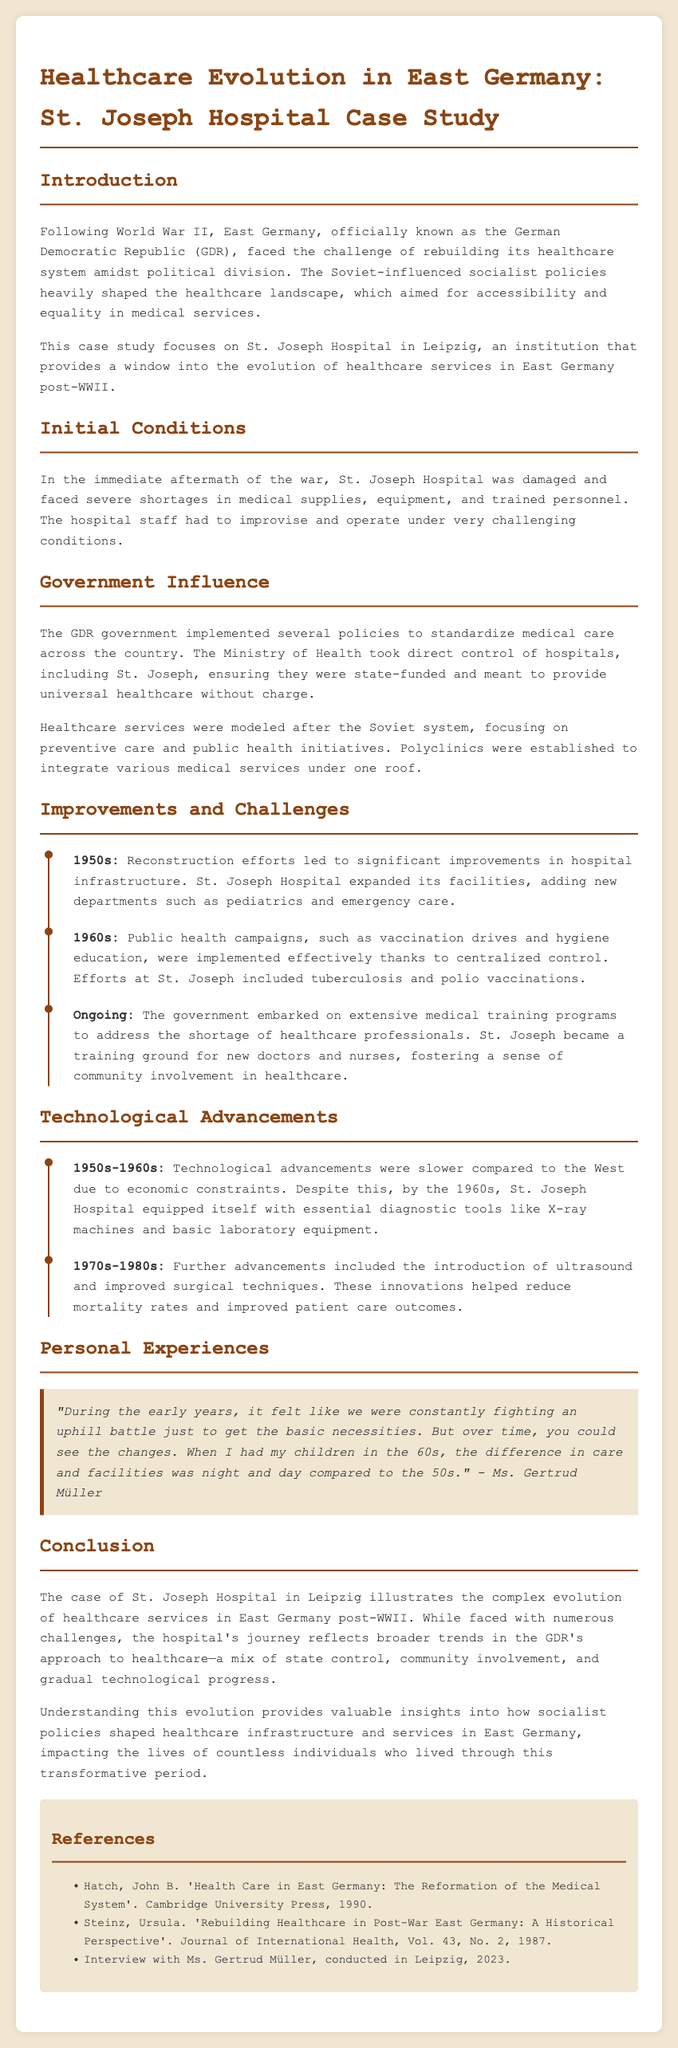What is the name of the hospital discussed in the case study? The hospital discussed in the case study is St. Joseph Hospital in Leipzig.
Answer: St. Joseph Hospital What year did the GDR officially come into existence? The German Democratic Republic (GDR) was established in 1949, following World War II.
Answer: 1949 What was a significant health campaign implemented in the 1960s? Public health campaigns in the 1960s included vaccination drives and hygiene education.
Answer: Vaccination drives Who conducted an interview that is referenced in the document? The document references an interview conducted with Ms. Gertrud Müller in Leipzig.
Answer: Ms. Gertrud Müller What essential diagnostic tools were introduced at St. Joseph Hospital by the 1960s? By the 1960s, St. Joseph Hospital equipped itself with X-ray machines and basic laboratory equipment.
Answer: X-ray machines What improvement was made to St. Joseph Hospital in the 1950s? Reconstruction efforts led to the expansion of St. Joseph Hospital's facilities and the addition of new departments like pediatrics.
Answer: Expanded facilities What aspect of healthcare did the government focus on in East Germany? The East German government focused on preventive care and public health initiatives in healthcare.
Answer: Preventive care What was the main challenge faced by St. Joseph Hospital immediately after WWII? The main challenge faced by St. Joseph Hospital post-WWII was severe shortages in medical supplies, equipment, and trained personnel.
Answer: Severe shortages In which decade were ultrasound and improved surgical techniques introduced? Ultrasound and improved surgical techniques were introduced in the 1970s-1980s at St. Joseph Hospital.
Answer: 1970s-1980s 